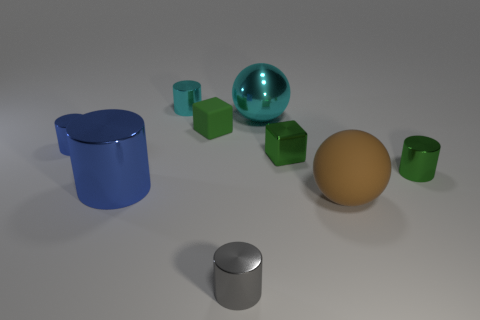Does the small metal cube have the same color as the tiny matte thing? Yes, the small metal cube and the tiny matte object, which appears to be a cube as well, share the same hue of green. However, the metal cube has a shiny, reflective surface, while the matte cube has a dull, non-reflective texture. 